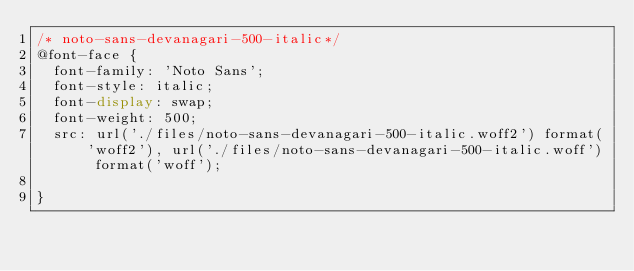Convert code to text. <code><loc_0><loc_0><loc_500><loc_500><_CSS_>/* noto-sans-devanagari-500-italic*/
@font-face {
  font-family: 'Noto Sans';
  font-style: italic;
  font-display: swap;
  font-weight: 500;
  src: url('./files/noto-sans-devanagari-500-italic.woff2') format('woff2'), url('./files/noto-sans-devanagari-500-italic.woff') format('woff');
  
}
</code> 